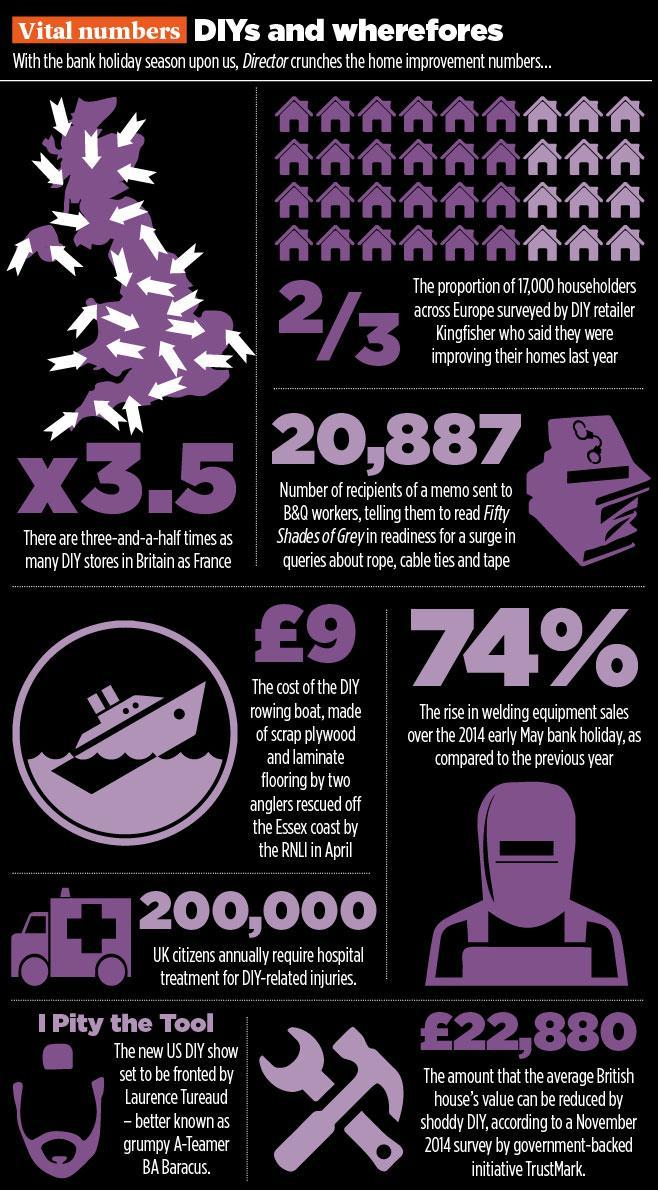What is the amount (in Pounds) that the average British house's value can be reduced by shoddy DIY according to a November 2014 survey by government-backed initiative TrustMark?
Answer the question with a short phrase. 22,880 How many UK citizens annually require hospital treatment for DIY-related injuries? 200,000 What is the percentge rise in welding equipment sales over the 2014 early may bank holiday as compared to the previous year? 74% 